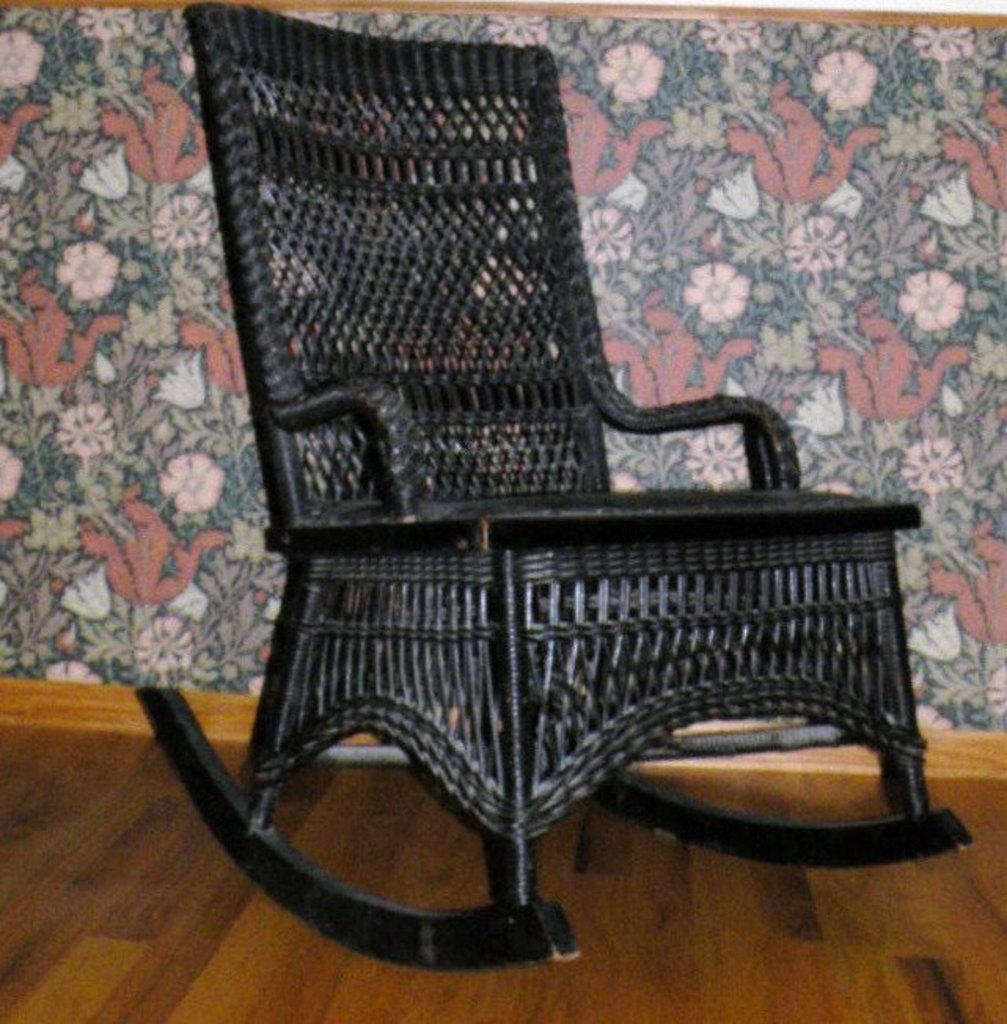What is the main object in the center of the image? There is a chair in the center of the image. What can be seen behind the chair? There is a wall visible in the background of the image. What is visible at the bottom of the image? The floor is visible at the bottom of the image. What type of pain is the chair experiencing in the image? Chairs do not experience pain, as they are inanimate objects. 